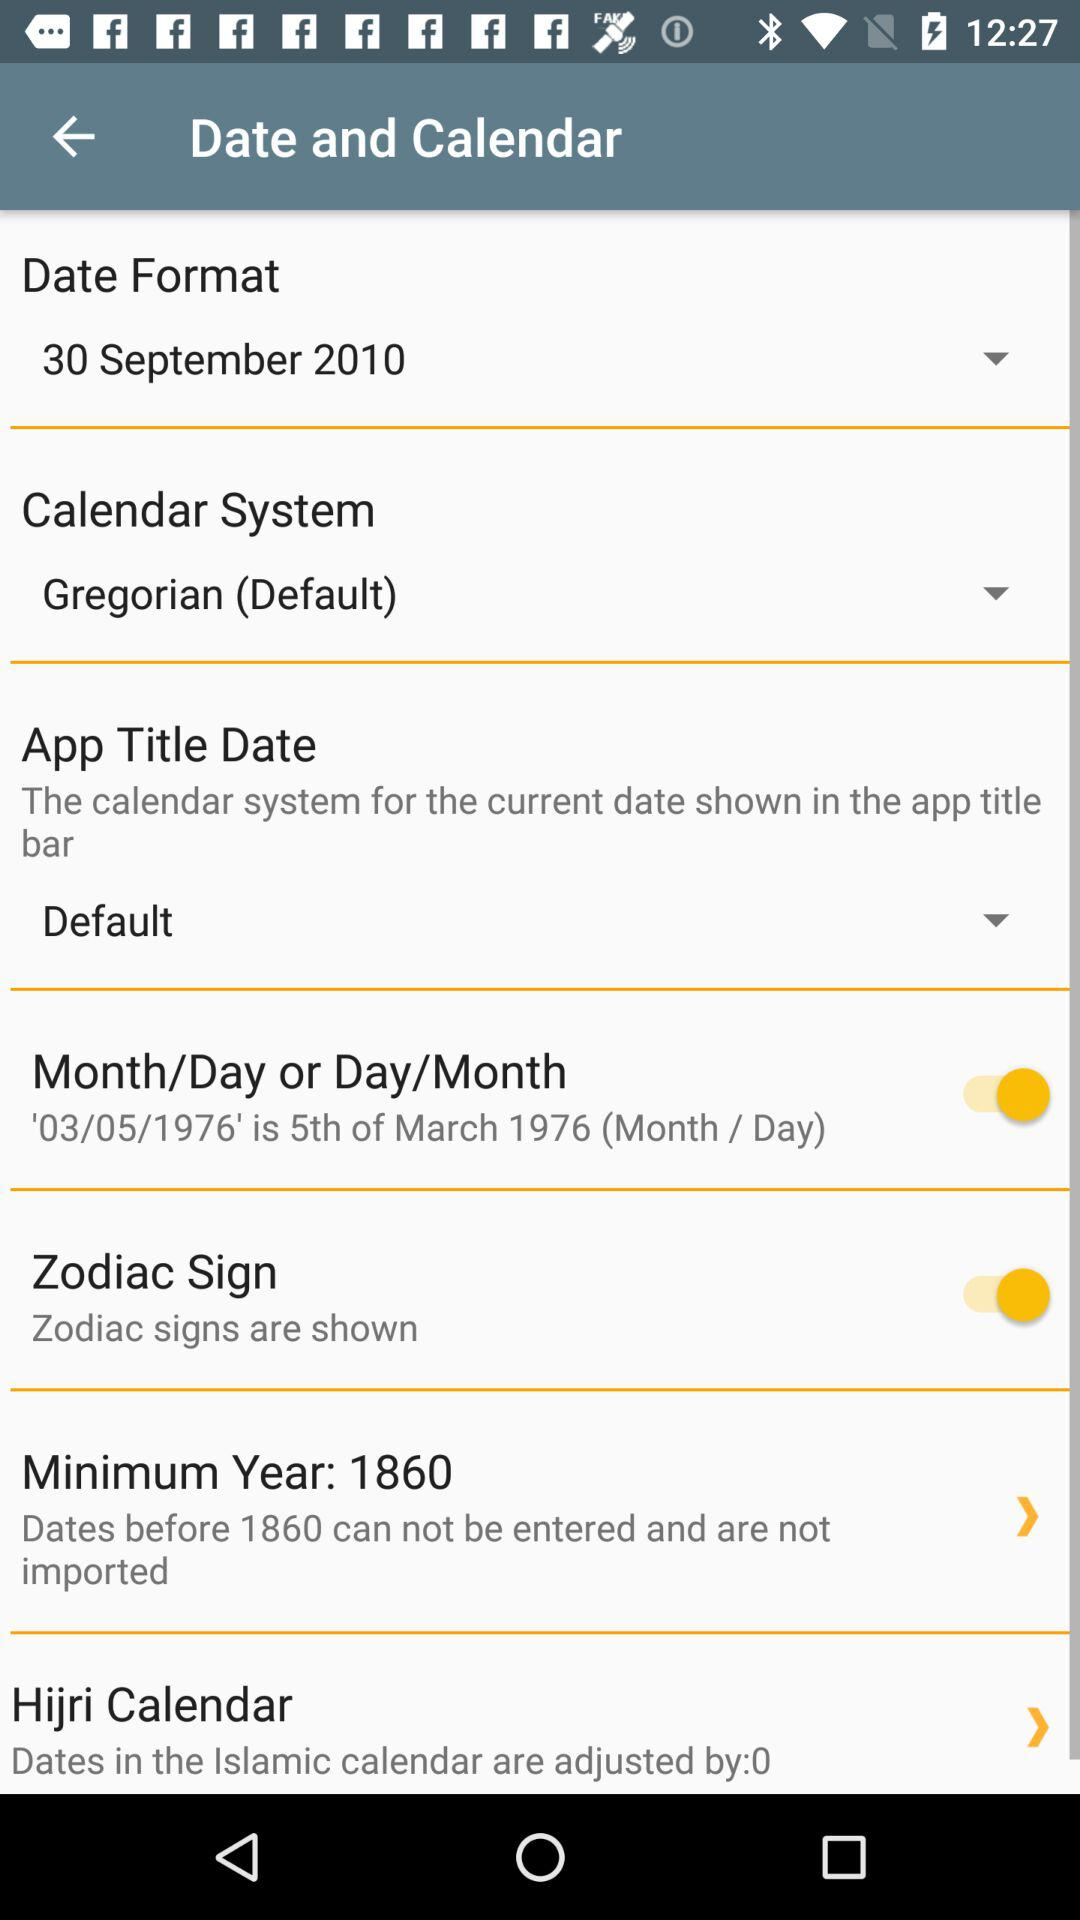Which date is selected? The selected date is 30 September 2010. 